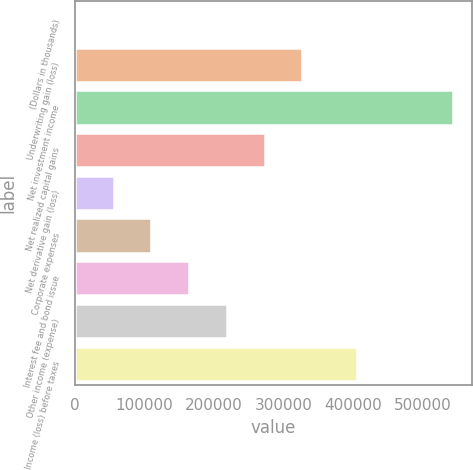Convert chart. <chart><loc_0><loc_0><loc_500><loc_500><bar_chart><fcel>(Dollars in thousands)<fcel>Underwriting gain (loss)<fcel>Net investment income<fcel>Net realized capital gains<fcel>Net derivative gain (loss)<fcel>Corporate expenses<fcel>Interest fee and bond issue<fcel>Other income (expense)<fcel>Income (loss) before taxes<nl><fcel>2017<fcel>326546<fcel>542898<fcel>272458<fcel>56105.1<fcel>110193<fcel>164281<fcel>218369<fcel>405184<nl></chart> 